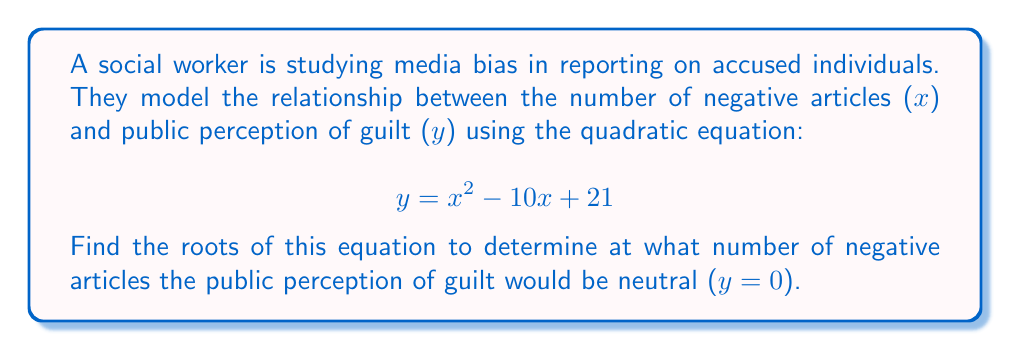Help me with this question. To find the roots of the quadratic equation, we need to solve for x when y = 0:

1) Set the equation equal to zero:
   $$0 = x^2 - 10x + 21$$

2) This is in the standard form of a quadratic equation: $ax^2 + bx + c = 0$
   Where $a = 1$, $b = -10$, and $c = 21$

3) We can solve this using the quadratic formula: $x = \frac{-b \pm \sqrt{b^2 - 4ac}}{2a}$

4) Substituting our values:
   $$x = \frac{-(-10) \pm \sqrt{(-10)^2 - 4(1)(21)}}{2(1)}$$

5) Simplify:
   $$x = \frac{10 \pm \sqrt{100 - 84}}{2} = \frac{10 \pm \sqrt{16}}{2} = \frac{10 \pm 4}{2}$$

6) This gives us two solutions:
   $$x = \frac{10 + 4}{2} = \frac{14}{2} = 7$$
   $$x = \frac{10 - 4}{2} = \frac{6}{2} = 3$$

Therefore, the roots of the equation are 7 and 3.
Answer: The roots of the equation are 7 and 3. This means the public perception of guilt would be neutral (y = 0) when there are either 7 or 3 negative articles. 